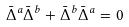Convert formula to latex. <formula><loc_0><loc_0><loc_500><loc_500>\bar { \Delta } ^ { a } \bar { \Delta } ^ { b } + \bar { \Delta } ^ { b } \bar { \Delta } ^ { a } = 0</formula> 